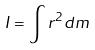<formula> <loc_0><loc_0><loc_500><loc_500>I = \int r ^ { 2 } d m</formula> 